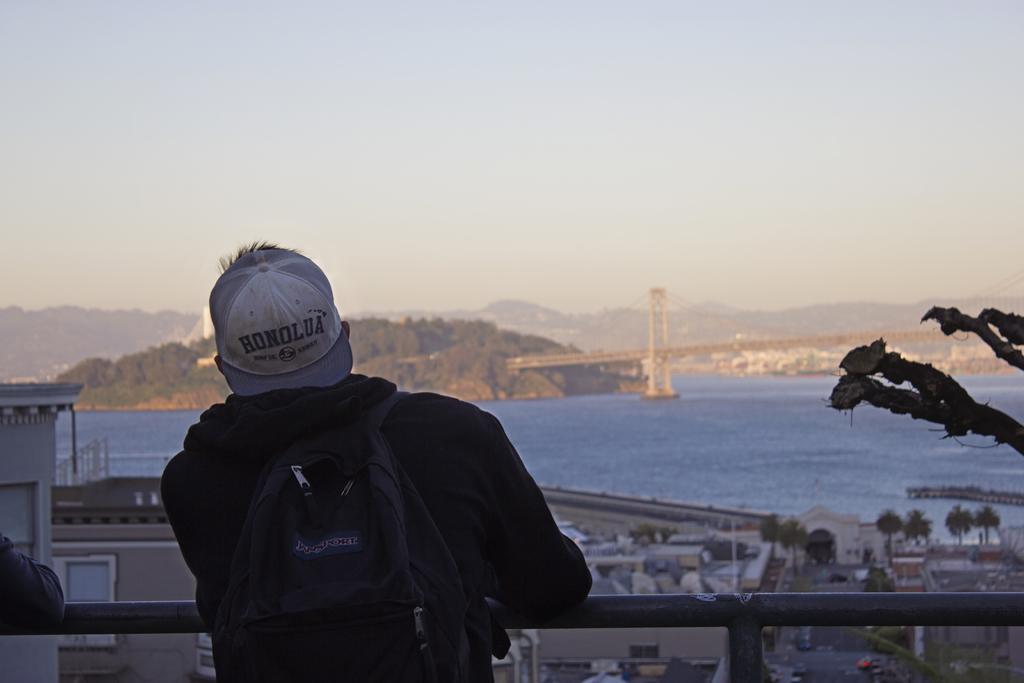Please provide a concise description of this image. In this image we can see a person wearing cap and bag. And the person is standing near to a railing. In the background there are buildings and trees. Also there is water and there is a bridge. And we can see hills and sky in the background. 